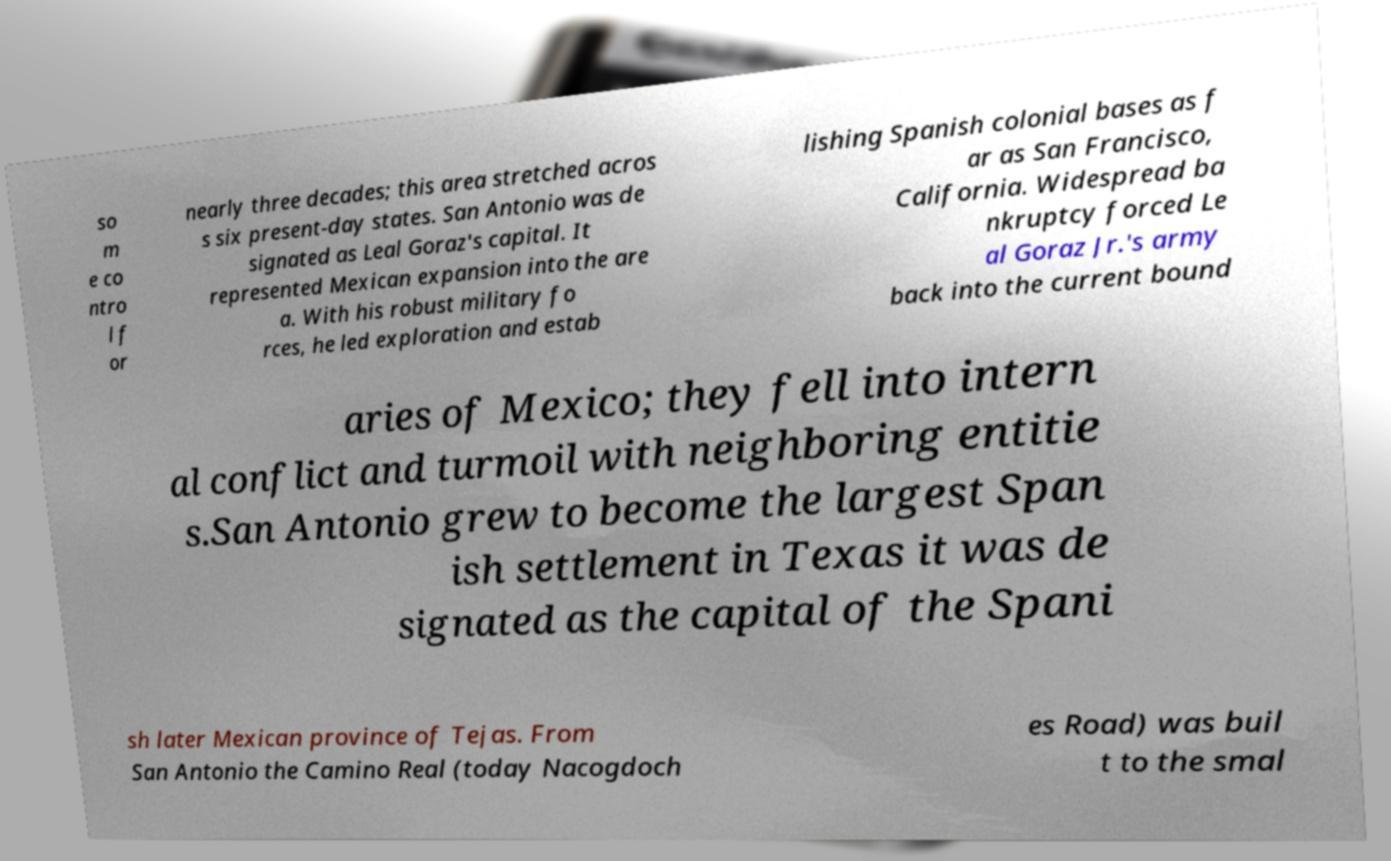Please read and relay the text visible in this image. What does it say? so m e co ntro l f or nearly three decades; this area stretched acros s six present-day states. San Antonio was de signated as Leal Goraz's capital. It represented Mexican expansion into the are a. With his robust military fo rces, he led exploration and estab lishing Spanish colonial bases as f ar as San Francisco, California. Widespread ba nkruptcy forced Le al Goraz Jr.'s army back into the current bound aries of Mexico; they fell into intern al conflict and turmoil with neighboring entitie s.San Antonio grew to become the largest Span ish settlement in Texas it was de signated as the capital of the Spani sh later Mexican province of Tejas. From San Antonio the Camino Real (today Nacogdoch es Road) was buil t to the smal 